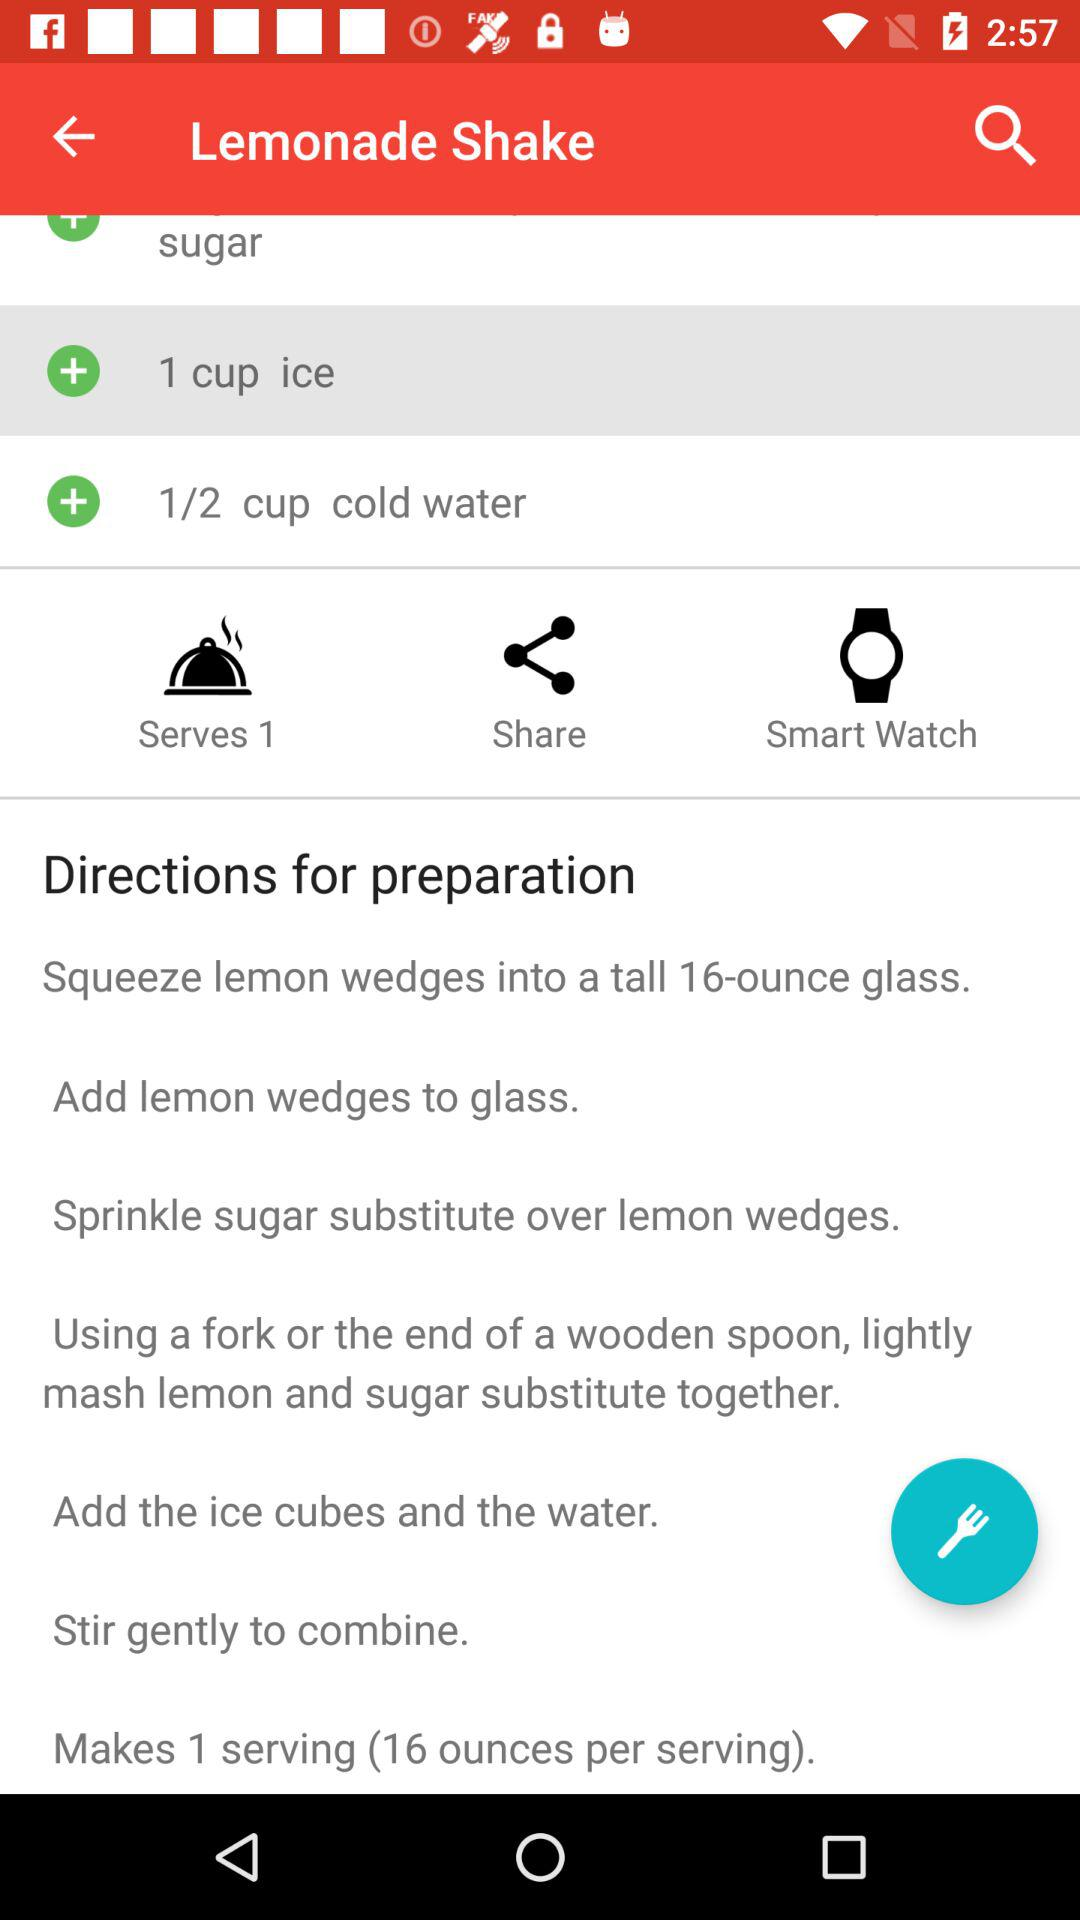What is the amount of cold water in a "Lemonade Shake"? The amount of cold water in a "Lemonade Shake" is 1/2 cup. 